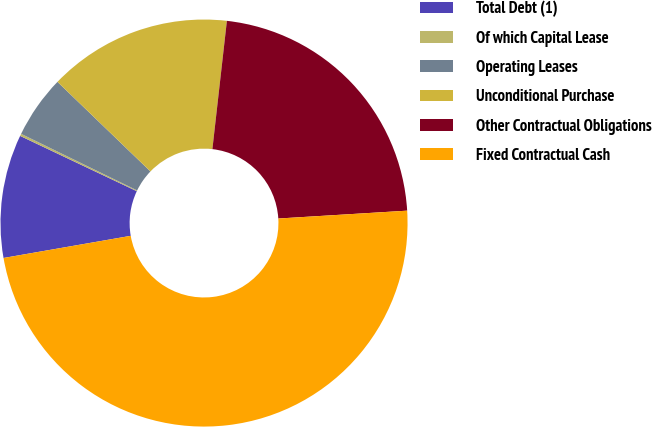Convert chart to OTSL. <chart><loc_0><loc_0><loc_500><loc_500><pie_chart><fcel>Total Debt (1)<fcel>Of which Capital Lease<fcel>Operating Leases<fcel>Unconditional Purchase<fcel>Other Contractual Obligations<fcel>Fixed Contractual Cash<nl><fcel>9.79%<fcel>0.18%<fcel>4.98%<fcel>14.59%<fcel>22.24%<fcel>48.23%<nl></chart> 